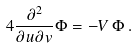<formula> <loc_0><loc_0><loc_500><loc_500>4 \frac { \partial ^ { 2 } } { \partial u \partial v } \Phi = - V \, \Phi \, .</formula> 